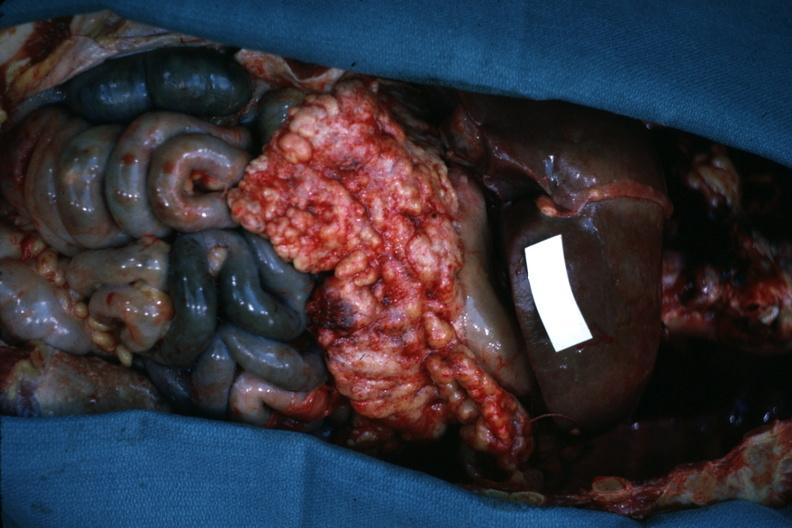s metastatic carcinoma present?
Answer the question using a single word or phrase. Yes 